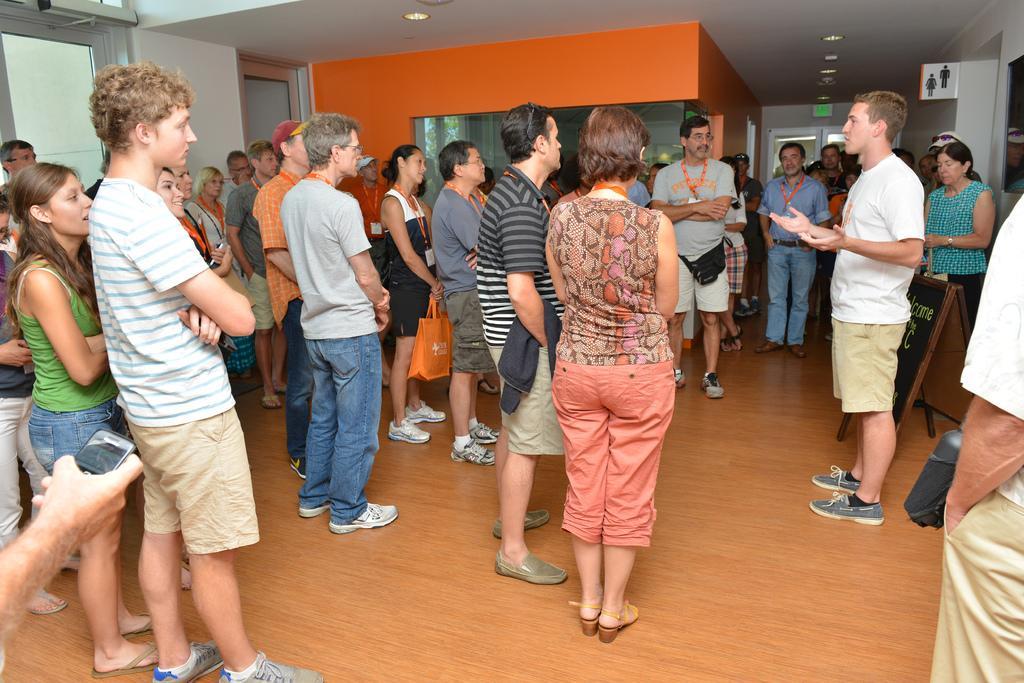Please provide a concise description of this image. In this picture we can see a group of people standing on the floor and a man in the white t shirt is explaining something. Behind the people there is an orange wall and a white wall and on the wall there are boards and at the top there are ceiling lights. 